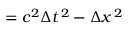<formula> <loc_0><loc_0><loc_500><loc_500>= c ^ { 2 } \Delta t ^ { \, 2 } - \Delta x ^ { \, 2 }</formula> 